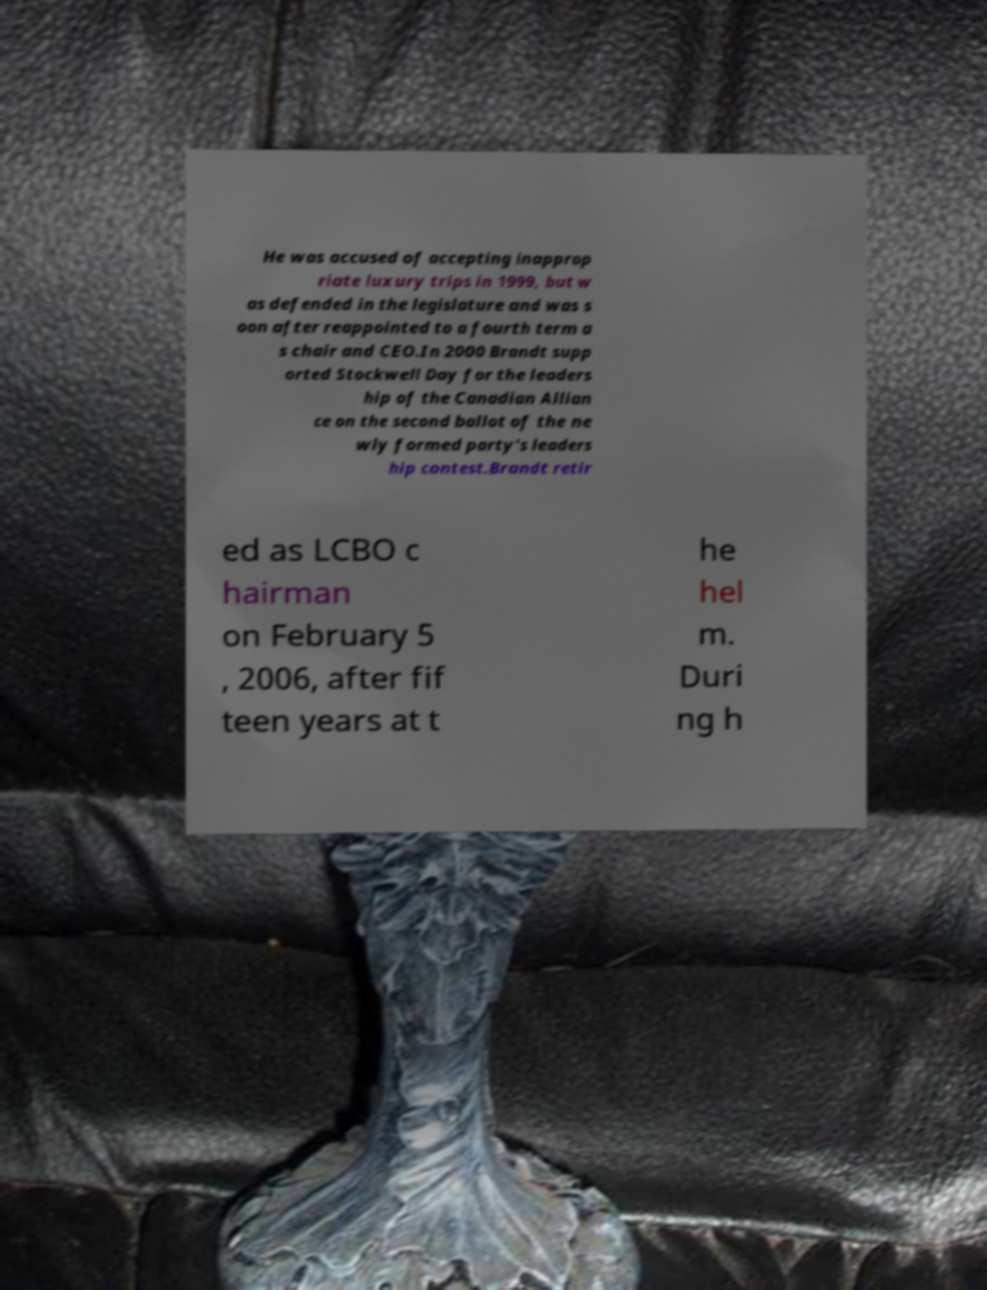Can you read and provide the text displayed in the image?This photo seems to have some interesting text. Can you extract and type it out for me? He was accused of accepting inapprop riate luxury trips in 1999, but w as defended in the legislature and was s oon after reappointed to a fourth term a s chair and CEO.In 2000 Brandt supp orted Stockwell Day for the leaders hip of the Canadian Allian ce on the second ballot of the ne wly formed party's leaders hip contest.Brandt retir ed as LCBO c hairman on February 5 , 2006, after fif teen years at t he hel m. Duri ng h 